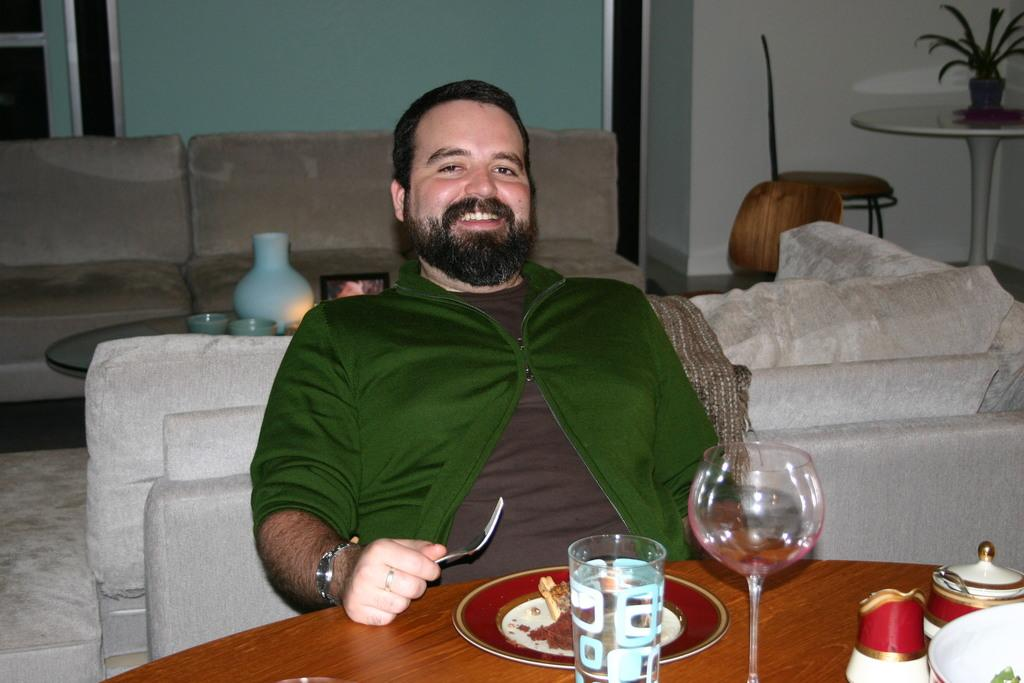What is the person in the image doing? The person is sitting on a sofa and at a table. What is the person holding in his hand? The person is holding a fork in his hand. What can be found on the table in the image? There are food items, glasses, and cups on the table. What is located behind the person? There are sofas, a table, a wall, and a house plant behind the person. What type of representative is standing next to the yak in the image? There is no representative or yak present in the image. 